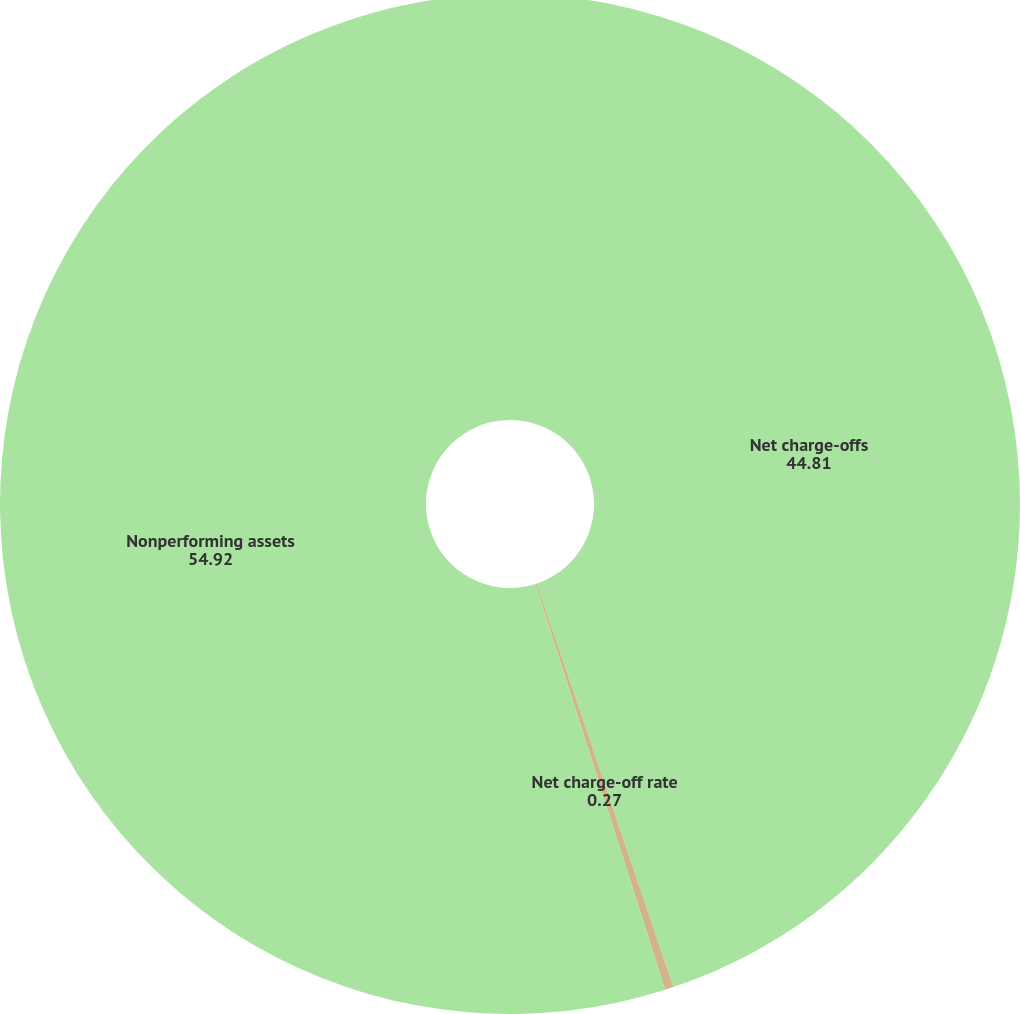Convert chart to OTSL. <chart><loc_0><loc_0><loc_500><loc_500><pie_chart><fcel>Net charge-offs<fcel>Net charge-off rate<fcel>Nonperforming assets<nl><fcel>44.81%<fcel>0.27%<fcel>54.92%<nl></chart> 